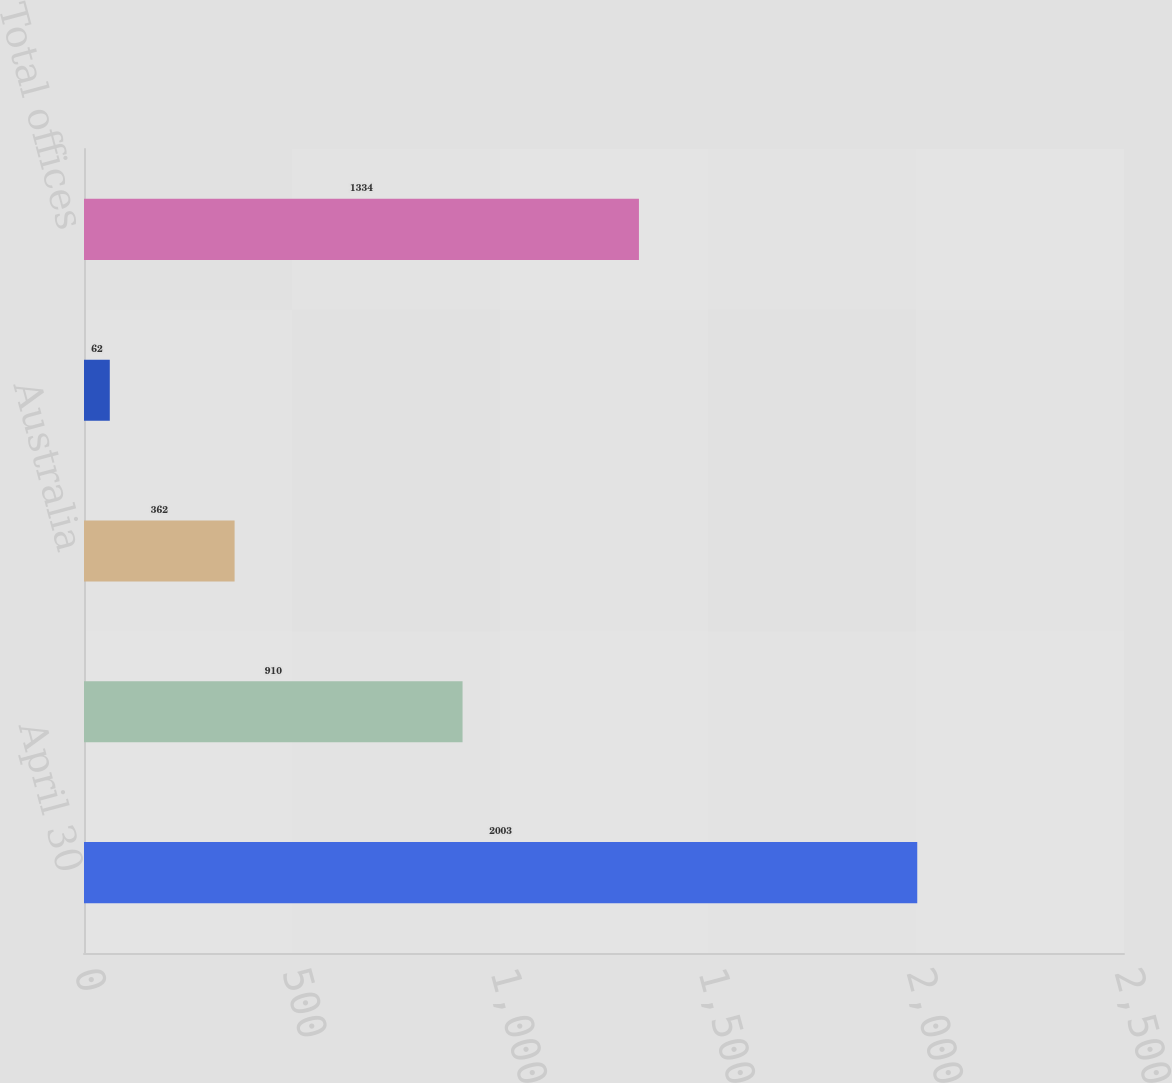Convert chart. <chart><loc_0><loc_0><loc_500><loc_500><bar_chart><fcel>April 30<fcel>Canada<fcel>Australia<fcel>Other<fcel>Total offices<nl><fcel>2003<fcel>910<fcel>362<fcel>62<fcel>1334<nl></chart> 